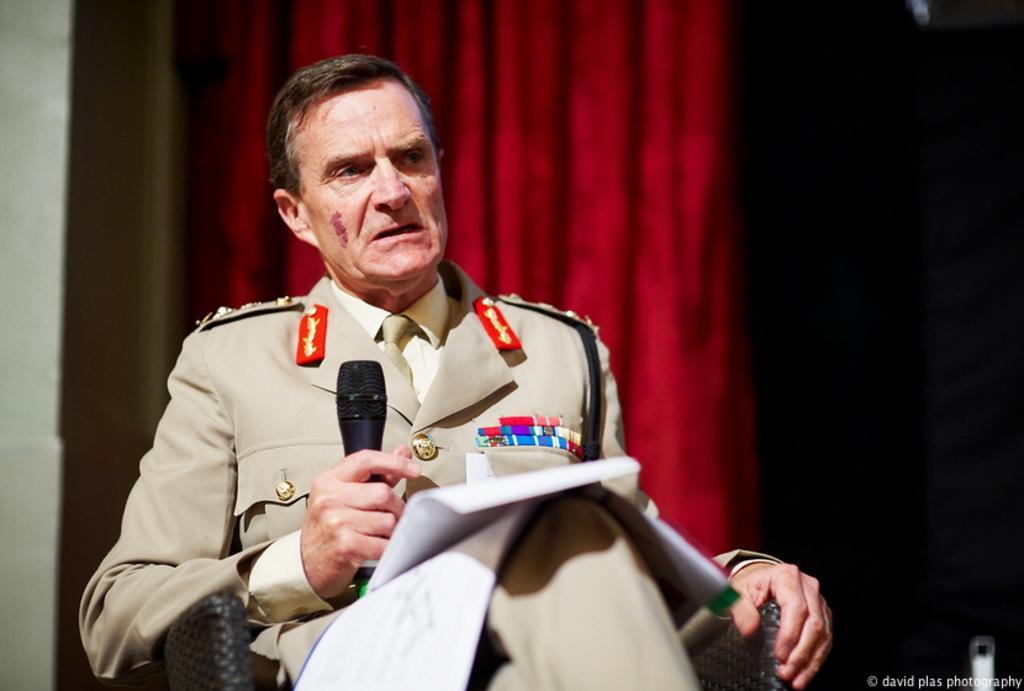Describe this image in one or two sentences. In this picture there is a man sitting on the chair and he is holding the microphone and talking. At the back there is a curtain. At the bottom right there is text. 